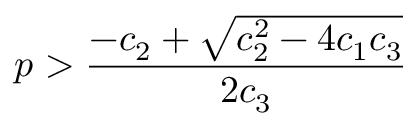Convert formula to latex. <formula><loc_0><loc_0><loc_500><loc_500>p > \frac { - c _ { 2 } + \sqrt { c _ { 2 } ^ { 2 } - 4 c _ { 1 } c _ { 3 } } } { 2 c _ { 3 } }</formula> 